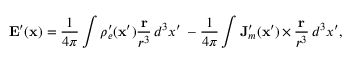Convert formula to latex. <formula><loc_0><loc_0><loc_500><loc_500>E ^ { \prime } ( x ) = \frac { 1 } { 4 \pi } \int \rho _ { e } ^ { \prime } ( x ^ { \prime } ) \frac { r } { r ^ { 3 } } \, d ^ { 3 } x ^ { \prime } \, - \frac { 1 } { 4 \pi } \int J _ { m } ^ { \prime } ( x ^ { \prime } ) \, { \times } \, \frac { r } { r ^ { 3 } } \, d ^ { 3 } x ^ { \prime } ,</formula> 